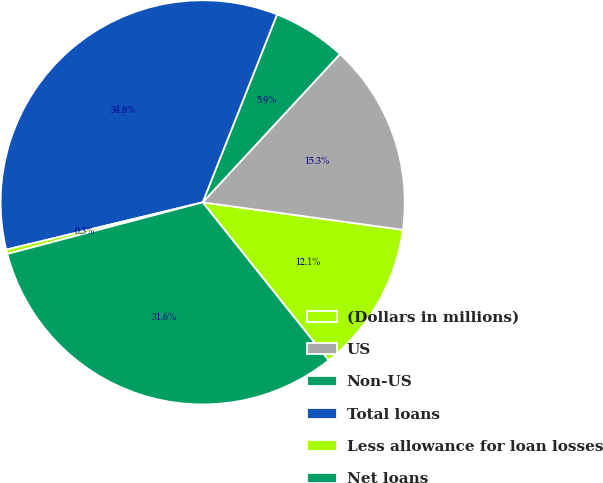Convert chart to OTSL. <chart><loc_0><loc_0><loc_500><loc_500><pie_chart><fcel>(Dollars in millions)<fcel>US<fcel>Non-US<fcel>Total loans<fcel>Less allowance for loan losses<fcel>Net loans<nl><fcel>12.12%<fcel>15.28%<fcel>5.9%<fcel>34.76%<fcel>0.35%<fcel>31.6%<nl></chart> 